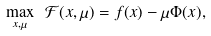<formula> <loc_0><loc_0><loc_500><loc_500>\max _ { x , \mu } \ \mathcal { F } ( x , \mu ) = f ( x ) - \mu \Phi ( x ) ,</formula> 